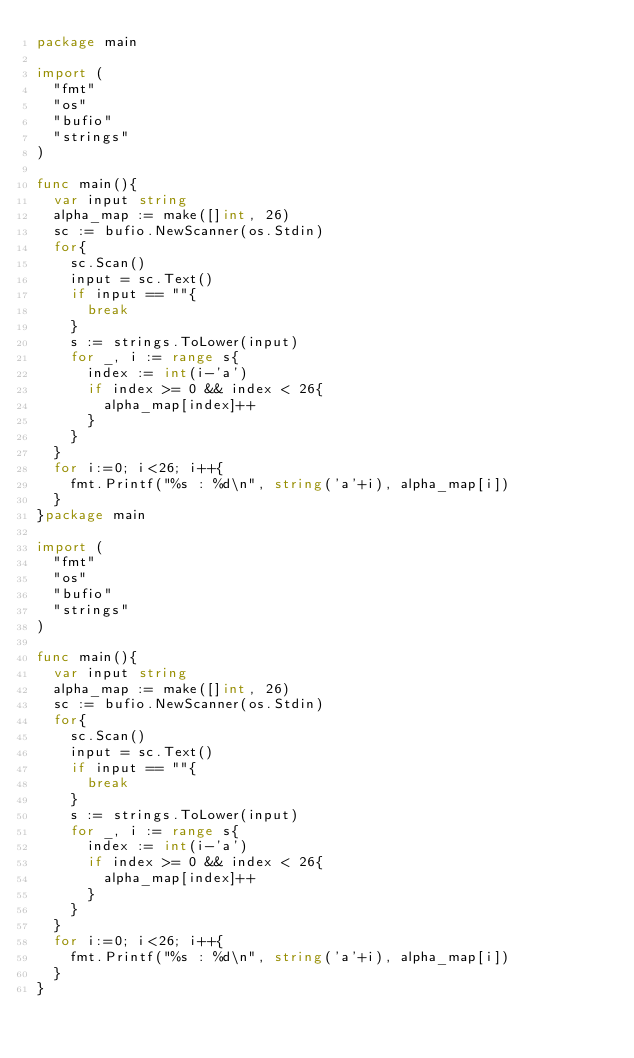Convert code to text. <code><loc_0><loc_0><loc_500><loc_500><_Go_>package main

import (
	"fmt"
	"os"
	"bufio"
	"strings"
)

func main(){
	var input string
	alpha_map := make([]int, 26)
	sc := bufio.NewScanner(os.Stdin)
	for{
		sc.Scan()
		input = sc.Text()
		if input == ""{
			break
		}
		s := strings.ToLower(input)
		for _, i := range s{
			index := int(i-'a')
			if index >= 0 && index < 26{
				alpha_map[index]++
			}
		}
	}
	for i:=0; i<26; i++{
		fmt.Printf("%s : %d\n", string('a'+i), alpha_map[i])
	}
}package main

import (
	"fmt"
	"os"
	"bufio"
	"strings"
)

func main(){
	var input string
	alpha_map := make([]int, 26)
	sc := bufio.NewScanner(os.Stdin)
	for{
		sc.Scan()
		input = sc.Text()
		if input == ""{
			break
		}
		s := strings.ToLower(input)
		for _, i := range s{
			index := int(i-'a')
			if index >= 0 && index < 26{
				alpha_map[index]++
			}
		}
	}
	for i:=0; i<26; i++{
		fmt.Printf("%s : %d\n", string('a'+i), alpha_map[i])
	}
}
</code> 